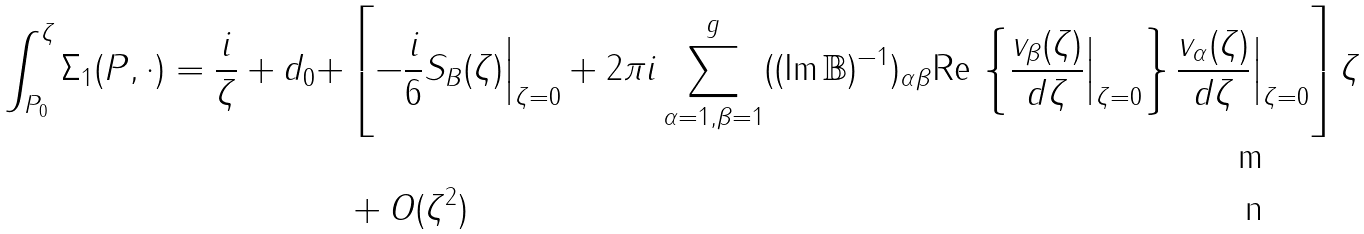<formula> <loc_0><loc_0><loc_500><loc_500>\int _ { P _ { 0 } } ^ { \zeta } \Sigma _ { 1 } ( P , \cdot ) = \frac { i } { \zeta } + d _ { 0 } + & \left [ - \frac { i } { 6 } S _ { B } ( \zeta ) \Big | _ { \zeta = 0 } + 2 \pi i \sum _ { \alpha = 1 , \beta = 1 } ^ { g } ( ( \text {Im} \, { \mathbb { B } } ) ^ { - 1 } ) _ { \alpha \beta } \text {Re} \, \left \{ \frac { v _ { \beta } ( \zeta ) } { d \zeta } \Big | _ { \zeta = 0 } \right \} \frac { v _ { \alpha } ( \zeta ) } { d \zeta } \Big | _ { \zeta = 0 } \right ] \zeta \\ & + O ( \zeta ^ { 2 } )</formula> 